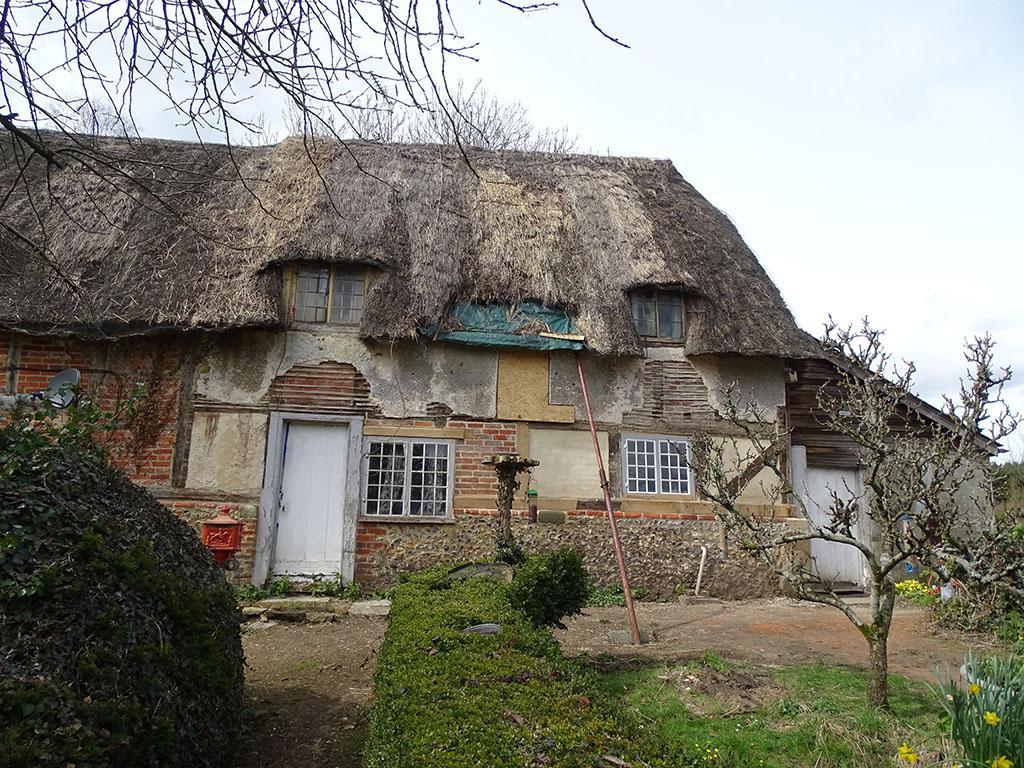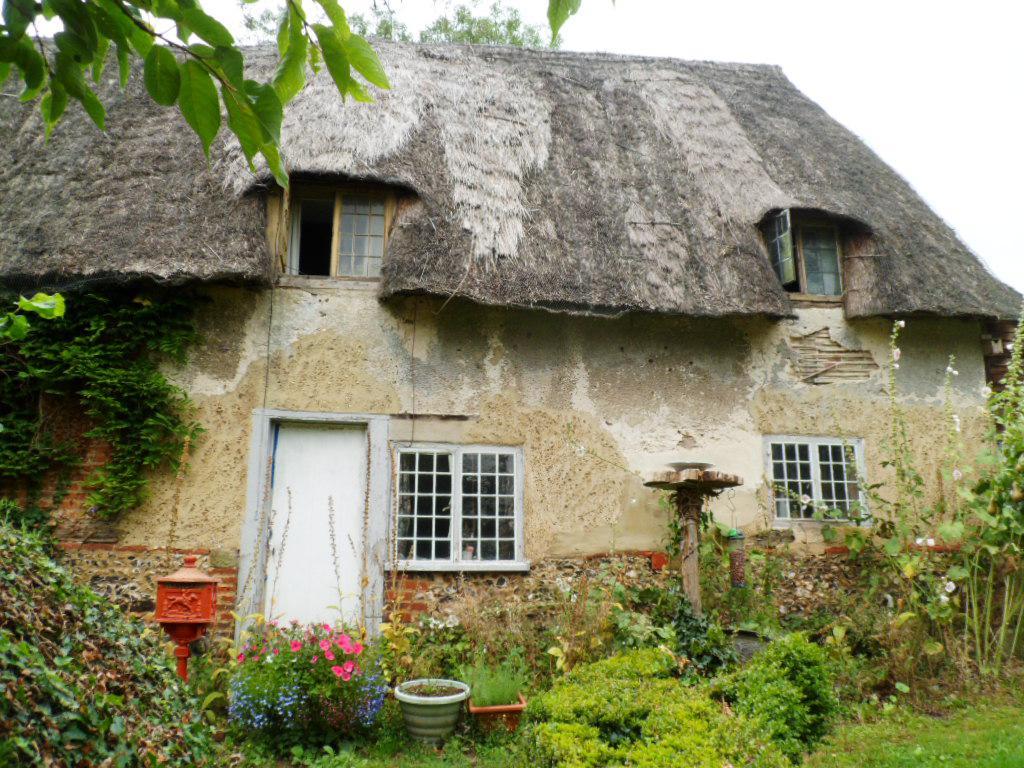The first image is the image on the left, the second image is the image on the right. Assess this claim about the two images: "In at least one image there is a house with exposed wood planks about a white front door.". Correct or not? Answer yes or no. Yes. The first image is the image on the left, the second image is the image on the right. For the images shown, is this caption "There is a house with a thatch roof with two dormered windows, the home has a dark colored door and black lines on the front of the home" true? Answer yes or no. No. 